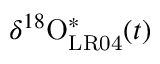<formula> <loc_0><loc_0><loc_500><loc_500>\delta ^ { 1 8 } O _ { L R 0 4 } ^ { \ast } ( t )</formula> 